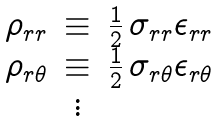Convert formula to latex. <formula><loc_0><loc_0><loc_500><loc_500>\begin{array} { l c l } \rho _ { r r } & \equiv & \frac { 1 } { 2 } \, \sigma _ { r r } \epsilon _ { r r } \\ \rho _ { r \theta } & \equiv & \frac { 1 } { 2 } \, \sigma _ { r \theta } \epsilon _ { r \theta } \\ & \vdots & \end{array}</formula> 